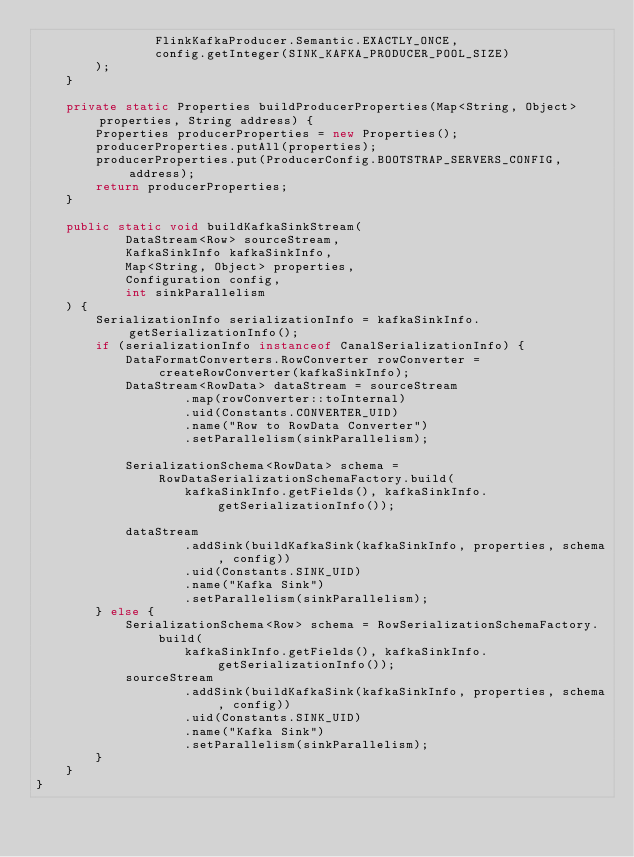Convert code to text. <code><loc_0><loc_0><loc_500><loc_500><_Java_>                FlinkKafkaProducer.Semantic.EXACTLY_ONCE,
                config.getInteger(SINK_KAFKA_PRODUCER_POOL_SIZE)
        );
    }

    private static Properties buildProducerProperties(Map<String, Object> properties, String address) {
        Properties producerProperties = new Properties();
        producerProperties.putAll(properties);
        producerProperties.put(ProducerConfig.BOOTSTRAP_SERVERS_CONFIG, address);
        return producerProperties;
    }

    public static void buildKafkaSinkStream(
            DataStream<Row> sourceStream,
            KafkaSinkInfo kafkaSinkInfo,
            Map<String, Object> properties,
            Configuration config,
            int sinkParallelism
    ) {
        SerializationInfo serializationInfo = kafkaSinkInfo.getSerializationInfo();
        if (serializationInfo instanceof CanalSerializationInfo) {
            DataFormatConverters.RowConverter rowConverter = createRowConverter(kafkaSinkInfo);
            DataStream<RowData> dataStream = sourceStream
                    .map(rowConverter::toInternal)
                    .uid(Constants.CONVERTER_UID)
                    .name("Row to RowData Converter")
                    .setParallelism(sinkParallelism);

            SerializationSchema<RowData> schema = RowDataSerializationSchemaFactory.build(
                    kafkaSinkInfo.getFields(), kafkaSinkInfo.getSerializationInfo());

            dataStream
                    .addSink(buildKafkaSink(kafkaSinkInfo, properties, schema, config))
                    .uid(Constants.SINK_UID)
                    .name("Kafka Sink")
                    .setParallelism(sinkParallelism);
        } else {
            SerializationSchema<Row> schema = RowSerializationSchemaFactory.build(
                    kafkaSinkInfo.getFields(), kafkaSinkInfo.getSerializationInfo());
            sourceStream
                    .addSink(buildKafkaSink(kafkaSinkInfo, properties, schema, config))
                    .uid(Constants.SINK_UID)
                    .name("Kafka Sink")
                    .setParallelism(sinkParallelism);
        }
    }
}
</code> 